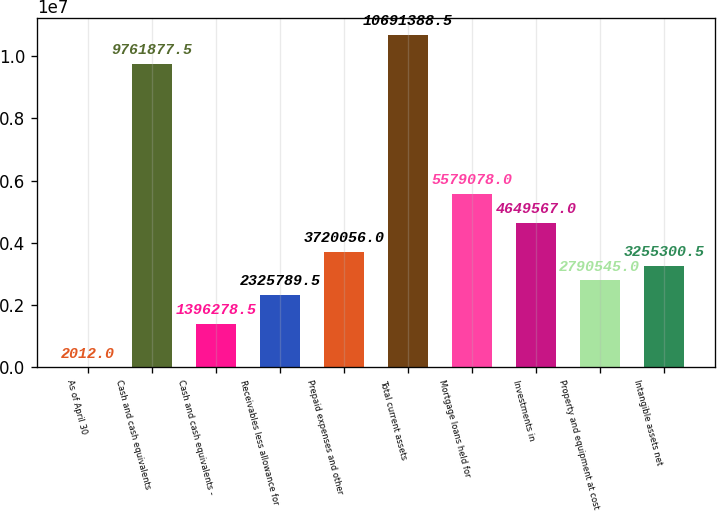Convert chart. <chart><loc_0><loc_0><loc_500><loc_500><bar_chart><fcel>As of April 30<fcel>Cash and cash equivalents<fcel>Cash and cash equivalents -<fcel>Receivables less allowance for<fcel>Prepaid expenses and other<fcel>Total current assets<fcel>Mortgage loans held for<fcel>Investments in<fcel>Property and equipment at cost<fcel>Intangible assets net<nl><fcel>2012<fcel>9.76188e+06<fcel>1.39628e+06<fcel>2.32579e+06<fcel>3.72006e+06<fcel>1.06914e+07<fcel>5.57908e+06<fcel>4.64957e+06<fcel>2.79054e+06<fcel>3.2553e+06<nl></chart> 